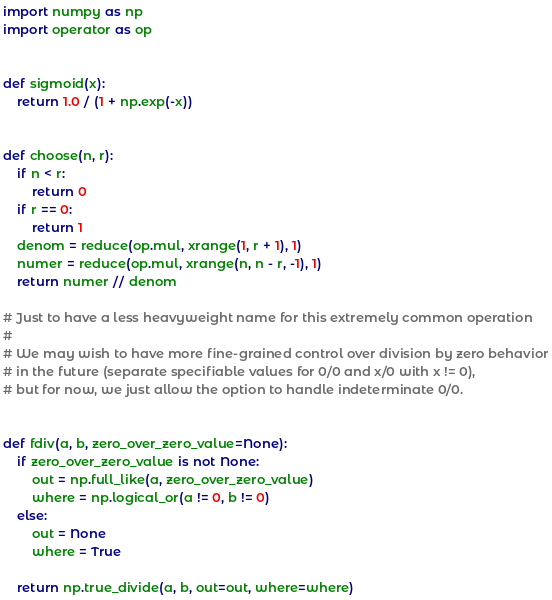<code> <loc_0><loc_0><loc_500><loc_500><_Python_>import numpy as np
import operator as op


def sigmoid(x):
    return 1.0 / (1 + np.exp(-x))


def choose(n, r):
    if n < r:
        return 0
    if r == 0:
        return 1
    denom = reduce(op.mul, xrange(1, r + 1), 1)
    numer = reduce(op.mul, xrange(n, n - r, -1), 1)
    return numer // denom

# Just to have a less heavyweight name for this extremely common operation
#
# We may wish to have more fine-grained control over division by zero behavior
# in the future (separate specifiable values for 0/0 and x/0 with x != 0),
# but for now, we just allow the option to handle indeterminate 0/0.


def fdiv(a, b, zero_over_zero_value=None):
    if zero_over_zero_value is not None:
        out = np.full_like(a, zero_over_zero_value)
        where = np.logical_or(a != 0, b != 0)
    else:
        out = None
        where = True

    return np.true_divide(a, b, out=out, where=where)
</code> 